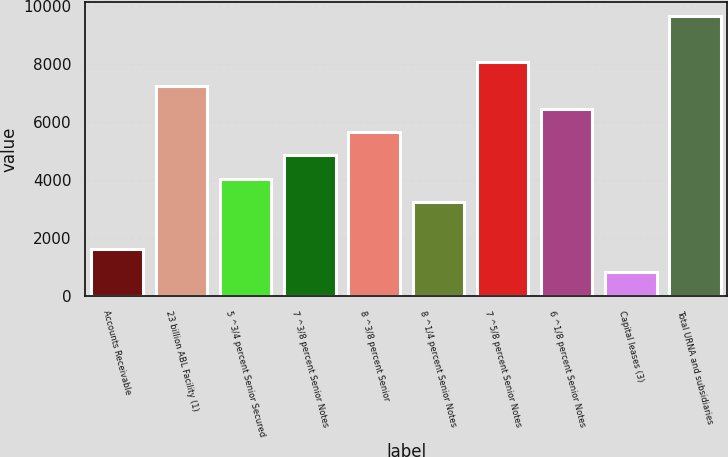Convert chart to OTSL. <chart><loc_0><loc_0><loc_500><loc_500><bar_chart><fcel>Accounts Receivable<fcel>23 billion ABL Facility (1)<fcel>5 ^3/4 percent Senior Secured<fcel>7 ^3/8 percent Senior Notes<fcel>8 ^3/8 percent Senior<fcel>8 ^1/4 percent Senior Notes<fcel>7 ^5/8 percent Senior Notes<fcel>6 ^1/8 percent Senior Notes<fcel>Capital leases (3)<fcel>Total URNA and subsidiaries<nl><fcel>1636<fcel>7250<fcel>4042<fcel>4844<fcel>5646<fcel>3240<fcel>8052<fcel>6448<fcel>834<fcel>9656<nl></chart> 